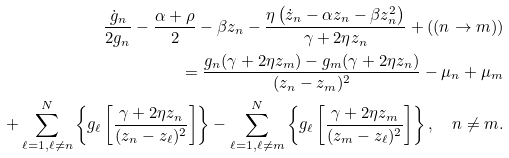<formula> <loc_0><loc_0><loc_500><loc_500>\frac { \dot { g } _ { n } } { 2 g _ { n } } - \frac { \alpha + \rho } { 2 } - \beta z _ { n } - \frac { \eta \left ( \dot { z } _ { n } - \alpha z _ { n } - \beta z _ { n } ^ { 2 } \right ) } { \gamma + 2 \eta z _ { n } } + ( ( n \rightarrow m ) ) \\ = \frac { g _ { n } ( \gamma + 2 \eta z _ { m } ) - g _ { m } ( \gamma + 2 \eta z _ { n } ) } { ( z _ { n } - z _ { m } ) ^ { 2 } } - \mu _ { n } + \mu _ { m } \\ \quad + \sum _ { \ell = 1 , \ell \neq n } ^ { N } \left \{ g _ { \ell } \left [ \frac { \gamma + 2 \eta z _ { n } } { ( z _ { n } - z _ { \ell } ) ^ { 2 } } \right ] \right \} - \sum _ { \ell = 1 , \ell \neq m } ^ { N } \left \{ g _ { \ell } \left [ \frac { \gamma + 2 \eta z _ { m } } { ( z _ { m } - z _ { \ell } ) ^ { 2 } } \right ] \right \} , \quad n \neq m .</formula> 